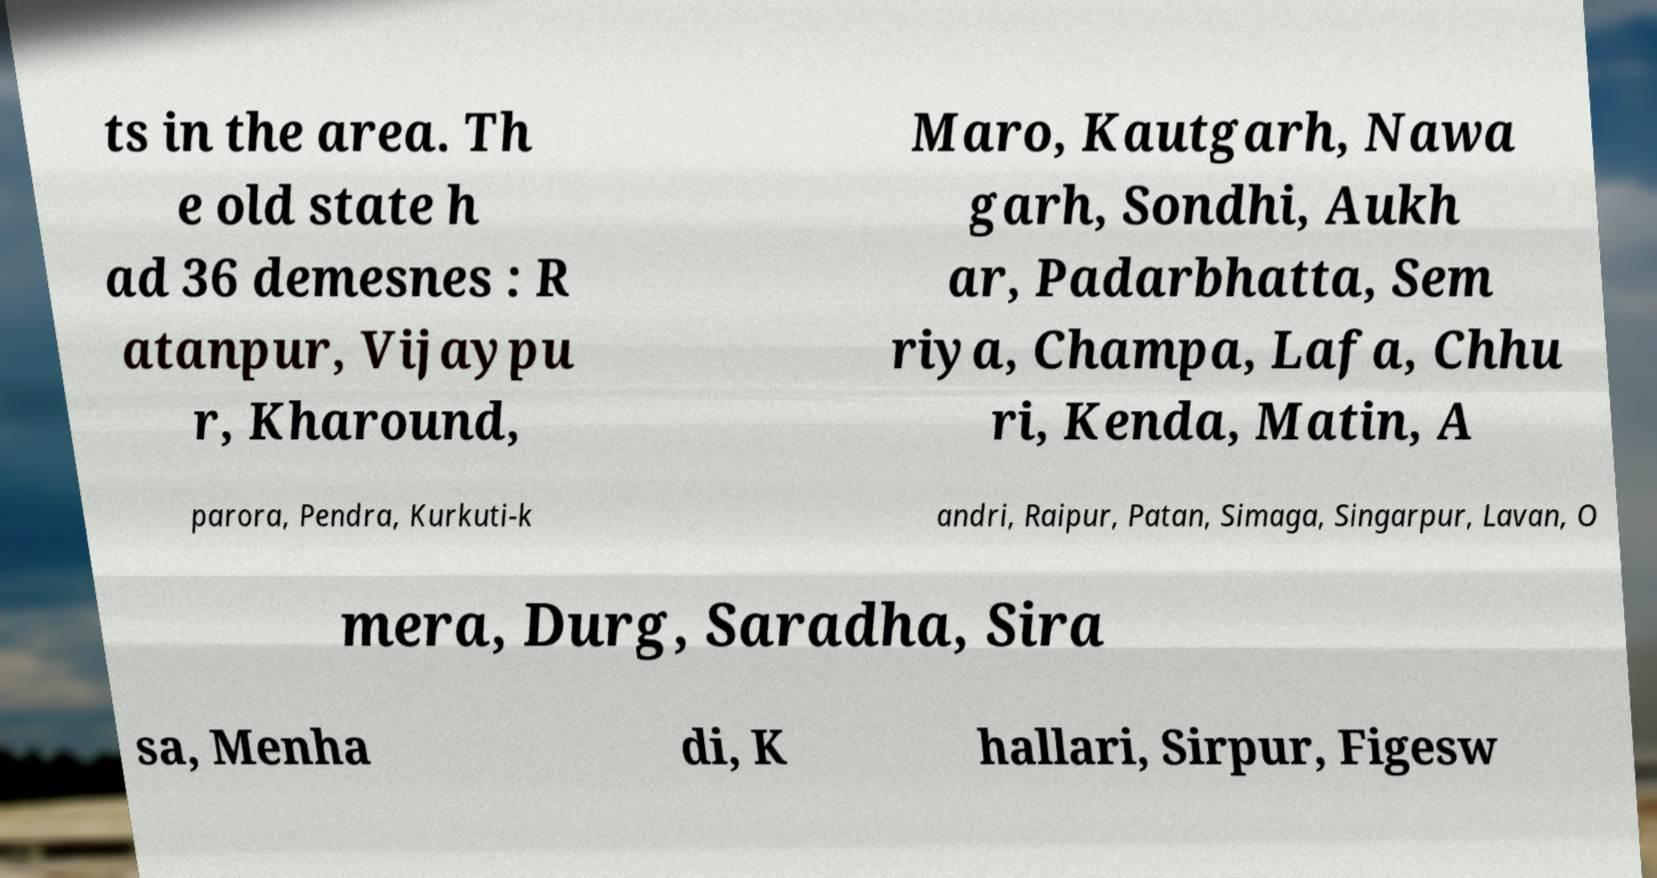Could you assist in decoding the text presented in this image and type it out clearly? ts in the area. Th e old state h ad 36 demesnes : R atanpur, Vijaypu r, Kharound, Maro, Kautgarh, Nawa garh, Sondhi, Aukh ar, Padarbhatta, Sem riya, Champa, Lafa, Chhu ri, Kenda, Matin, A parora, Pendra, Kurkuti-k andri, Raipur, Patan, Simaga, Singarpur, Lavan, O mera, Durg, Saradha, Sira sa, Menha di, K hallari, Sirpur, Figesw 